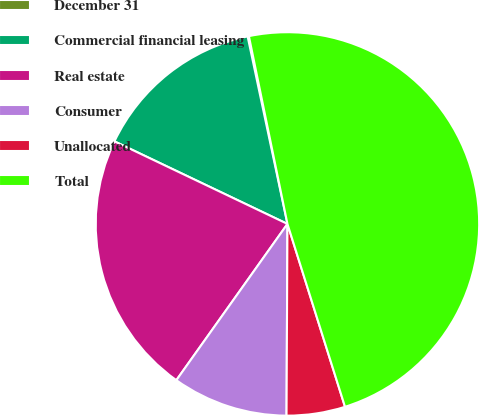Convert chart to OTSL. <chart><loc_0><loc_0><loc_500><loc_500><pie_chart><fcel>December 31<fcel>Commercial financial leasing<fcel>Real estate<fcel>Consumer<fcel>Unallocated<fcel>Total<nl><fcel>0.11%<fcel>14.58%<fcel>22.25%<fcel>9.76%<fcel>4.93%<fcel>48.37%<nl></chart> 